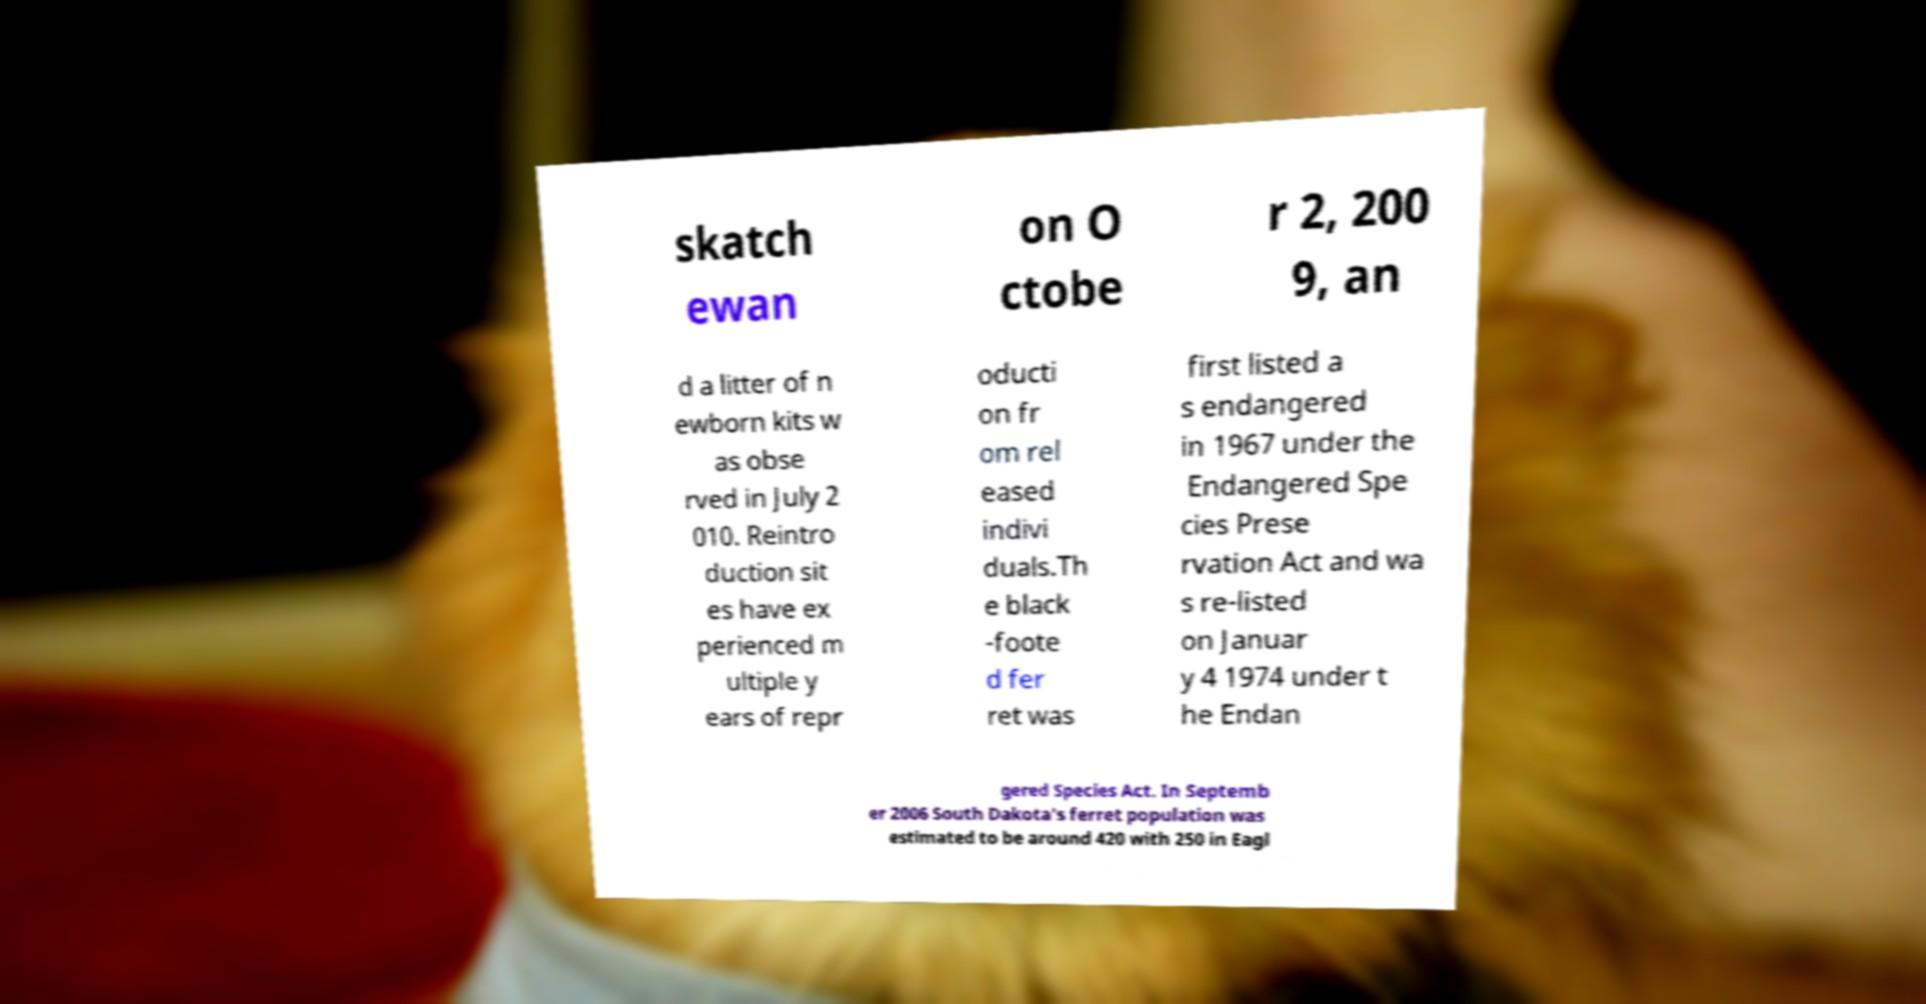Could you extract and type out the text from this image? skatch ewan on O ctobe r 2, 200 9, an d a litter of n ewborn kits w as obse rved in July 2 010. Reintro duction sit es have ex perienced m ultiple y ears of repr oducti on fr om rel eased indivi duals.Th e black -foote d fer ret was first listed a s endangered in 1967 under the Endangered Spe cies Prese rvation Act and wa s re-listed on Januar y 4 1974 under t he Endan gered Species Act. In Septemb er 2006 South Dakota's ferret population was estimated to be around 420 with 250 in Eagl 